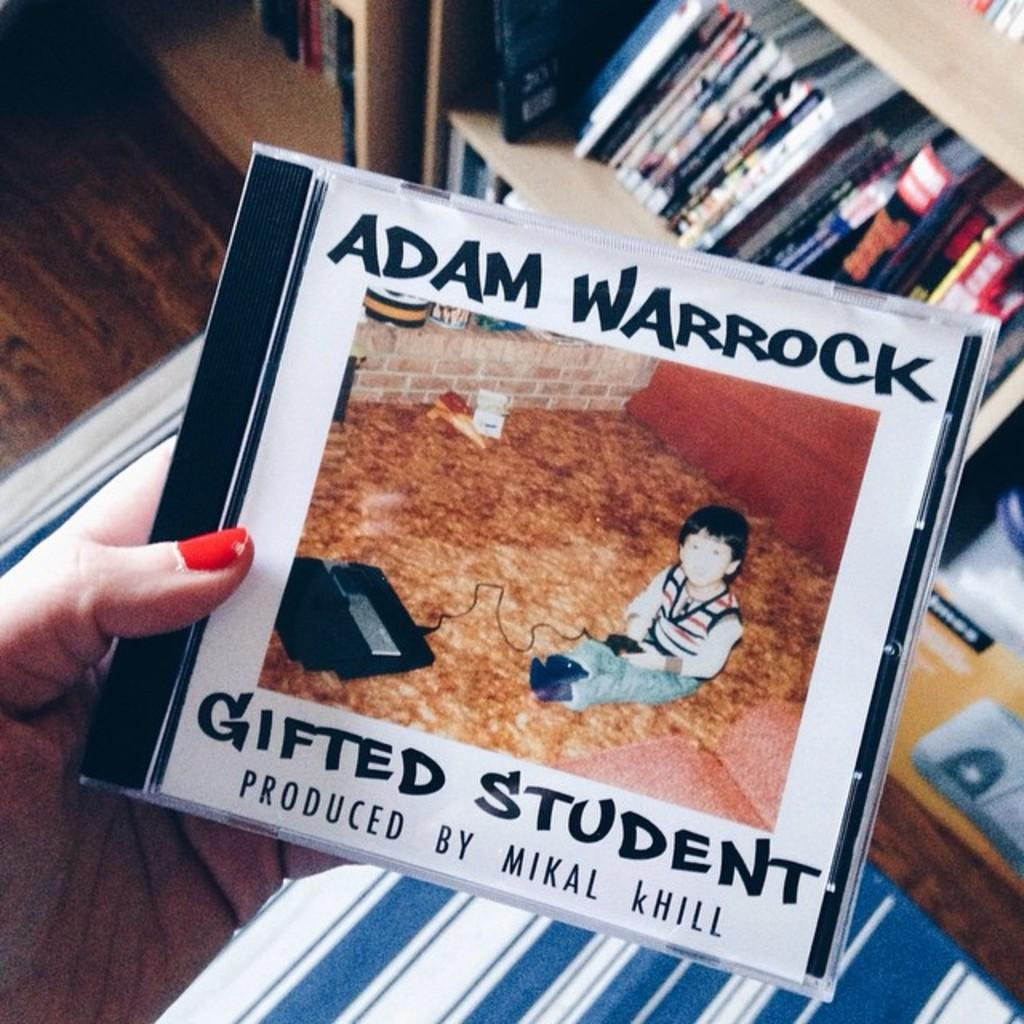<image>
Give a short and clear explanation of the subsequent image. a cd of Adam Warrock Gifted Student produced by Mikal KHill 